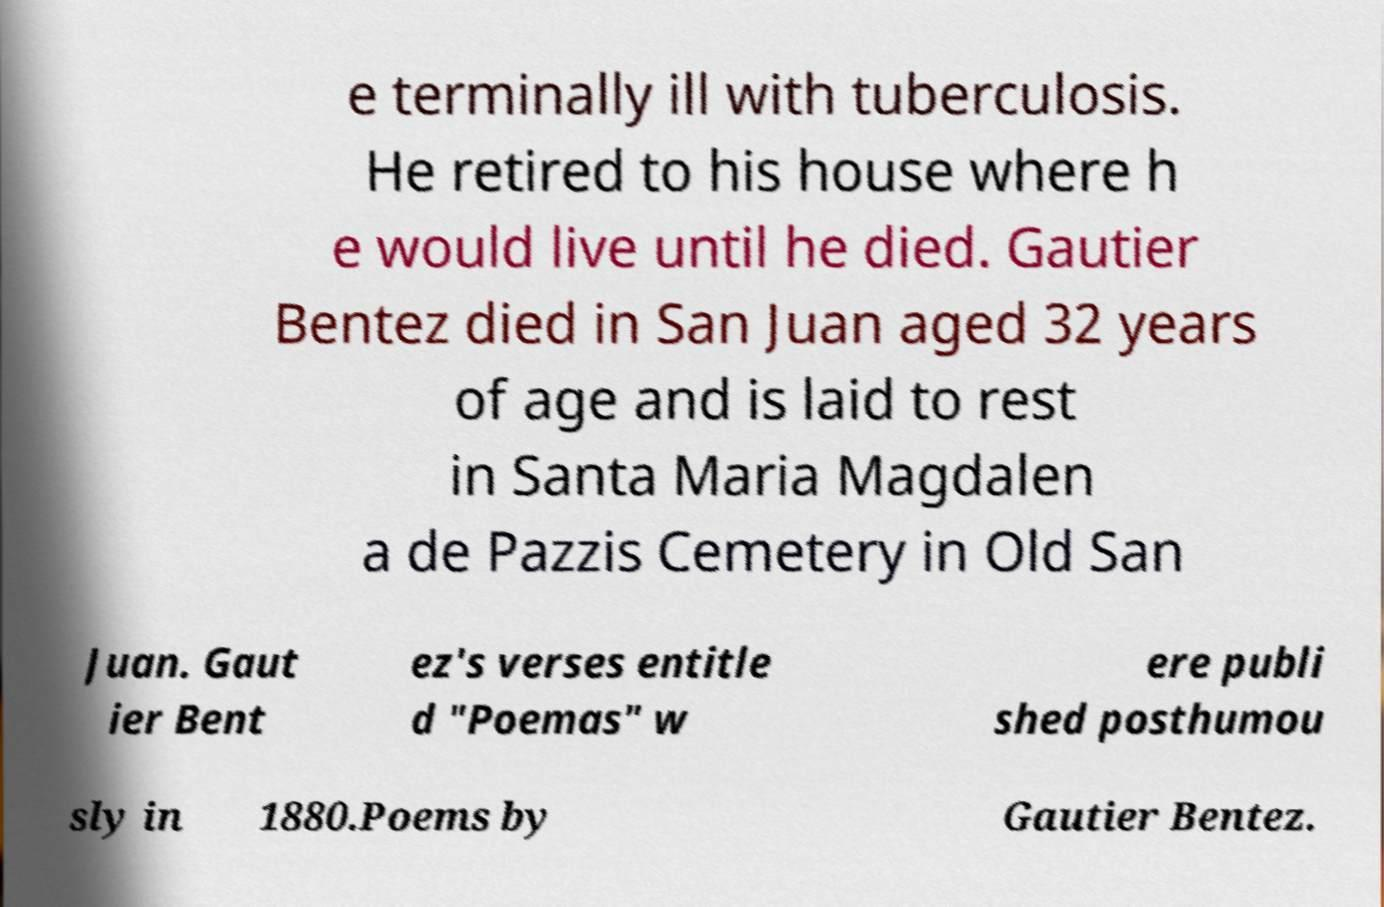For documentation purposes, I need the text within this image transcribed. Could you provide that? e terminally ill with tuberculosis. He retired to his house where h e would live until he died. Gautier Bentez died in San Juan aged 32 years of age and is laid to rest in Santa Maria Magdalen a de Pazzis Cemetery in Old San Juan. Gaut ier Bent ez's verses entitle d "Poemas" w ere publi shed posthumou sly in 1880.Poems by Gautier Bentez. 